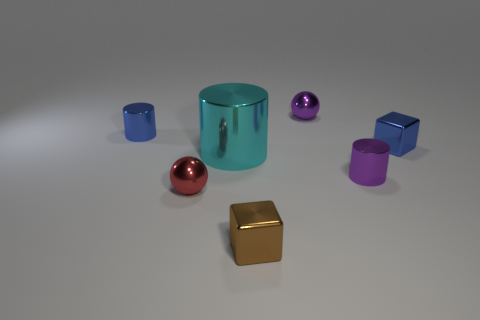Subtract all tiny blue cylinders. How many cylinders are left? 2 Add 1 cyan shiny things. How many objects exist? 8 Subtract all blocks. How many objects are left? 5 Subtract 2 cubes. How many cubes are left? 0 Subtract all cyan cylinders. How many cylinders are left? 2 Subtract 0 gray balls. How many objects are left? 7 Subtract all gray balls. Subtract all green cubes. How many balls are left? 2 Subtract all large blue shiny cylinders. Subtract all brown blocks. How many objects are left? 6 Add 4 small red balls. How many small red balls are left? 5 Add 6 yellow spheres. How many yellow spheres exist? 6 